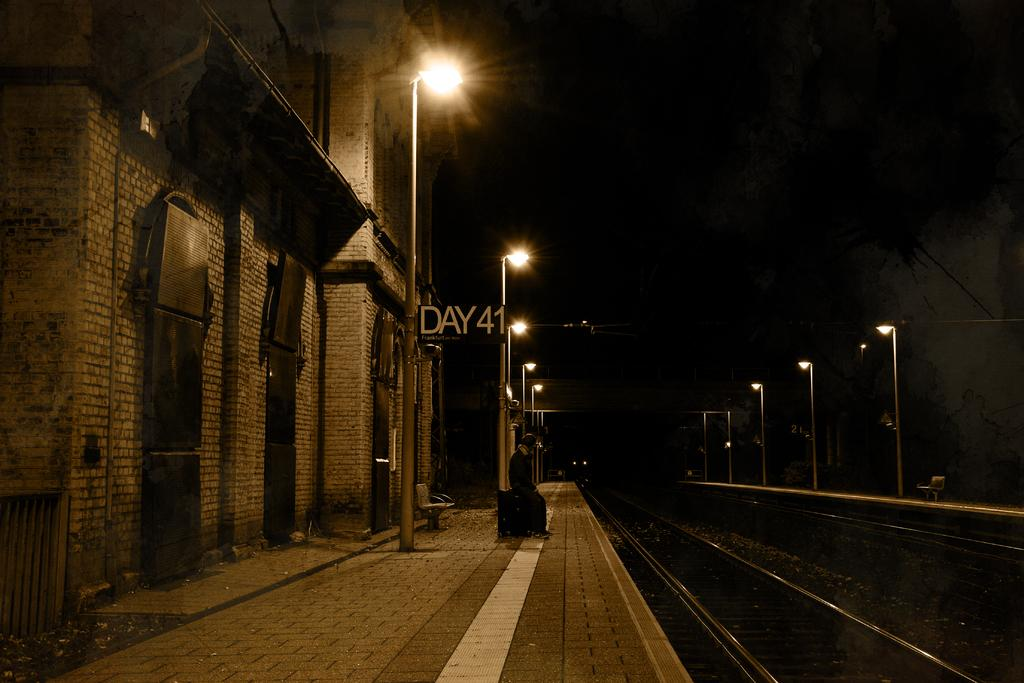<image>
Provide a brief description of the given image. An empty and dark train platform has a sign that says Day 41, Frankfurt. 